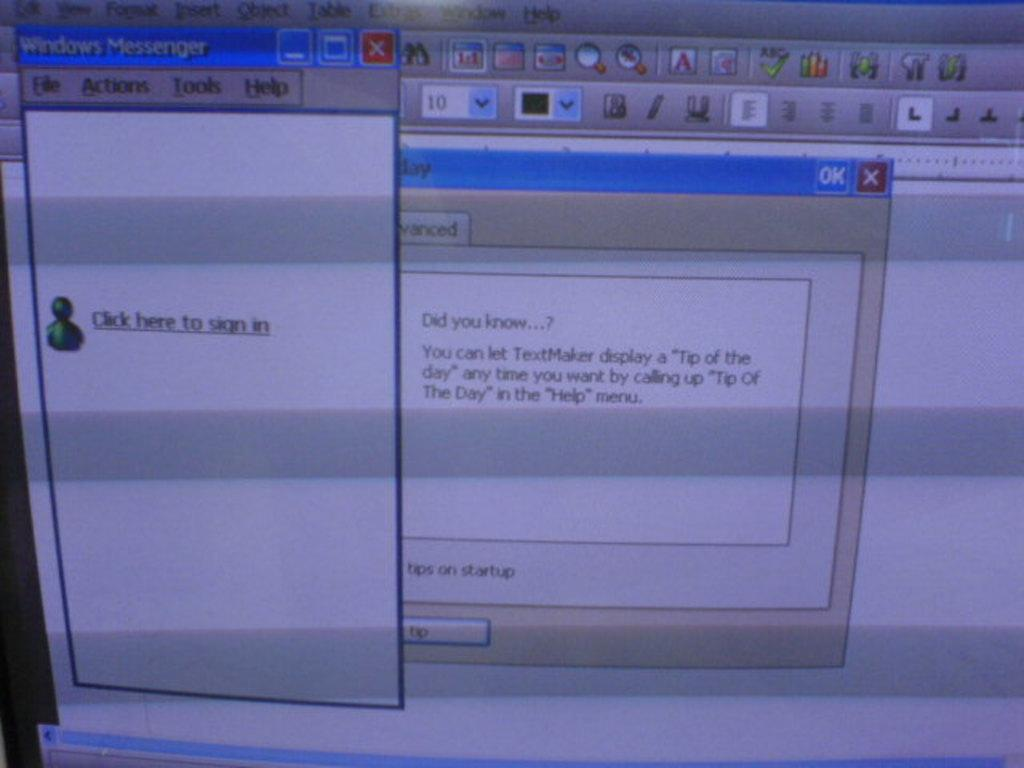<image>
Present a compact description of the photo's key features. A computer screen is showing a pop up to sign in to an account. 